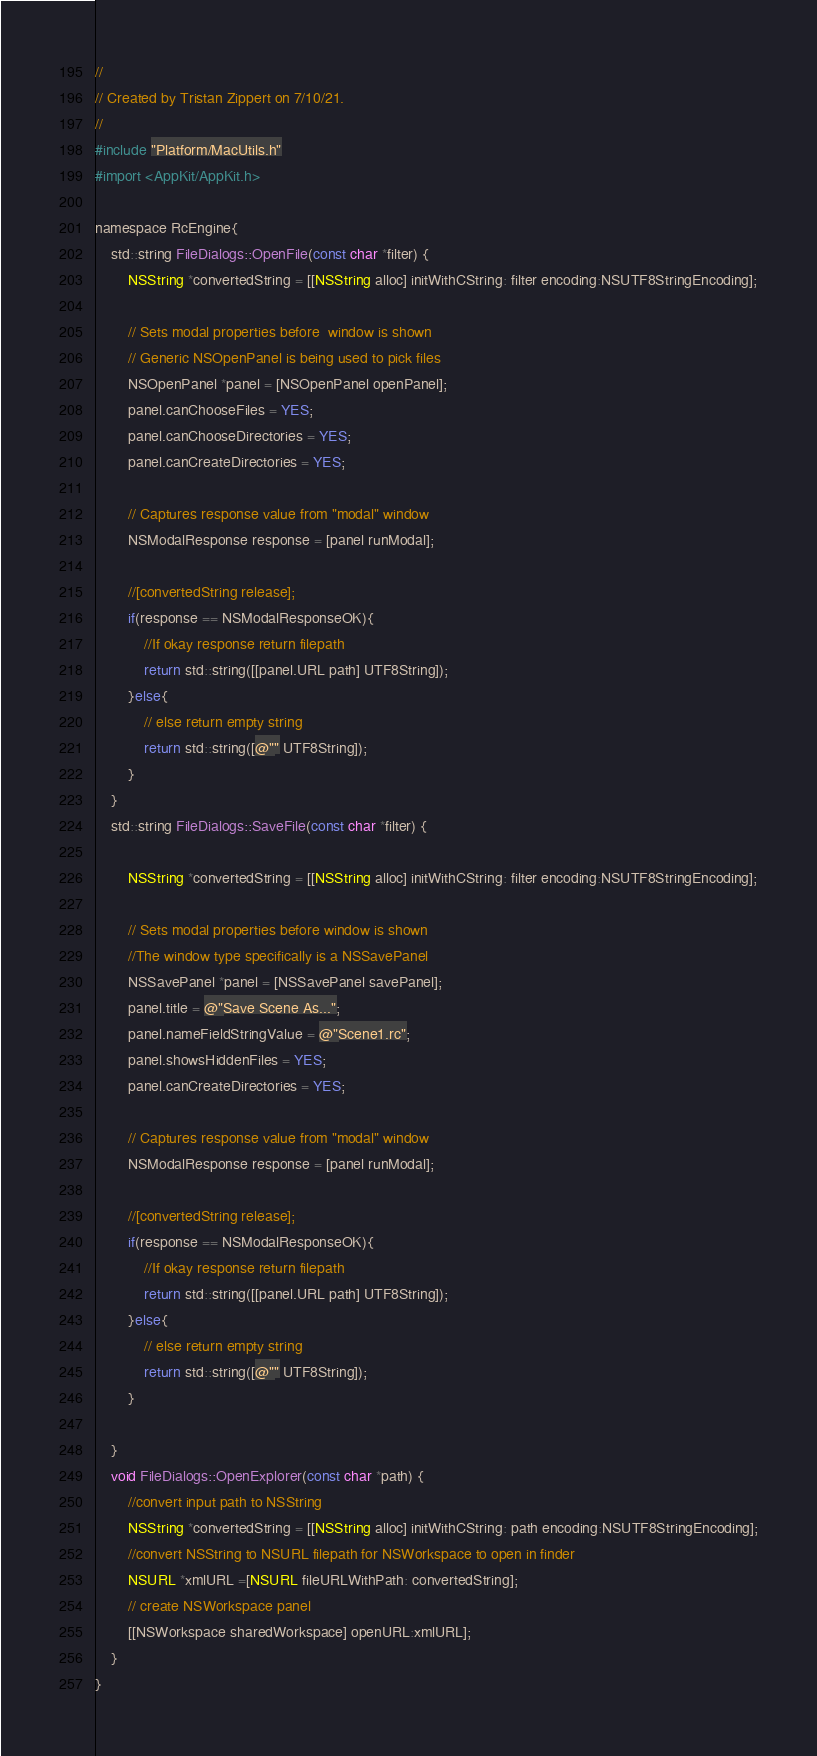Convert code to text. <code><loc_0><loc_0><loc_500><loc_500><_ObjectiveC_>//
// Created by Tristan Zippert on 7/10/21.
//
#include "Platform/MacUtils.h"
#import <AppKit/AppKit.h>

namespace RcEngine{
    std::string FileDialogs::OpenFile(const char *filter) {
        NSString *convertedString = [[NSString alloc] initWithCString: filter encoding:NSUTF8StringEncoding];

        // Sets modal properties before  window is shown
        // Generic NSOpenPanel is being used to pick files
        NSOpenPanel *panel = [NSOpenPanel openPanel];
        panel.canChooseFiles = YES;
        panel.canChooseDirectories = YES;
        panel.canCreateDirectories = YES;

        // Captures response value from "modal" window
        NSModalResponse response = [panel runModal];

        //[convertedString release];
        if(response == NSModalResponseOK){
            //If okay response return filepath
            return std::string([[panel.URL path] UTF8String]);
        }else{
            // else return empty string
            return std::string([@"" UTF8String]);
        }
    }
    std::string FileDialogs::SaveFile(const char *filter) {

        NSString *convertedString = [[NSString alloc] initWithCString: filter encoding:NSUTF8StringEncoding];

        // Sets modal properties before window is shown
        //The window type specifically is a NSSavePanel
        NSSavePanel *panel = [NSSavePanel savePanel];
        panel.title = @"Save Scene As...";
        panel.nameFieldStringValue = @"Scene1.rc";
        panel.showsHiddenFiles = YES;
        panel.canCreateDirectories = YES;

        // Captures response value from "modal" window
        NSModalResponse response = [panel runModal];

        //[convertedString release];
        if(response == NSModalResponseOK){
            //If okay response return filepath
            return std::string([[panel.URL path] UTF8String]);
        }else{
            // else return empty string
            return std::string([@"" UTF8String]);
        }

    }
    void FileDialogs::OpenExplorer(const char *path) {
        //convert input path to NSString
        NSString *convertedString = [[NSString alloc] initWithCString: path encoding:NSUTF8StringEncoding];
        //convert NSString to NSURL filepath for NSWorkspace to open in finder
        NSURL *xmlURL =[NSURL fileURLWithPath: convertedString];
        // create NSWorkspace panel
        [[NSWorkspace sharedWorkspace] openURL:xmlURL];
    }
}</code> 